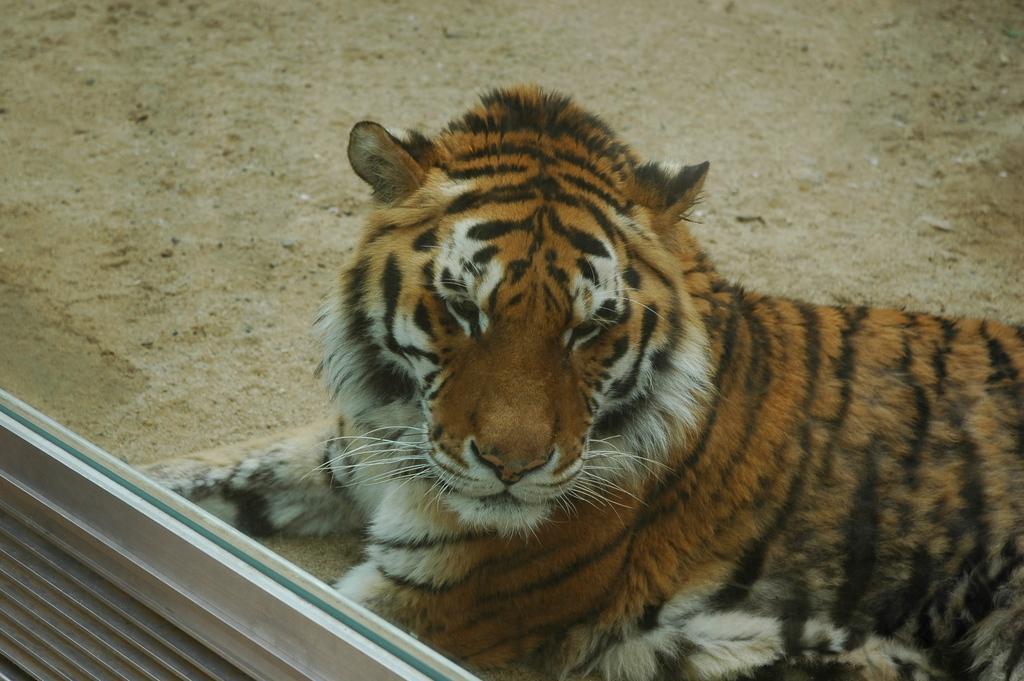In one or two sentences, can you explain what this image depicts? In this image there is a tiger sitting on the land. Left bottom there is a wall having a glass window. 